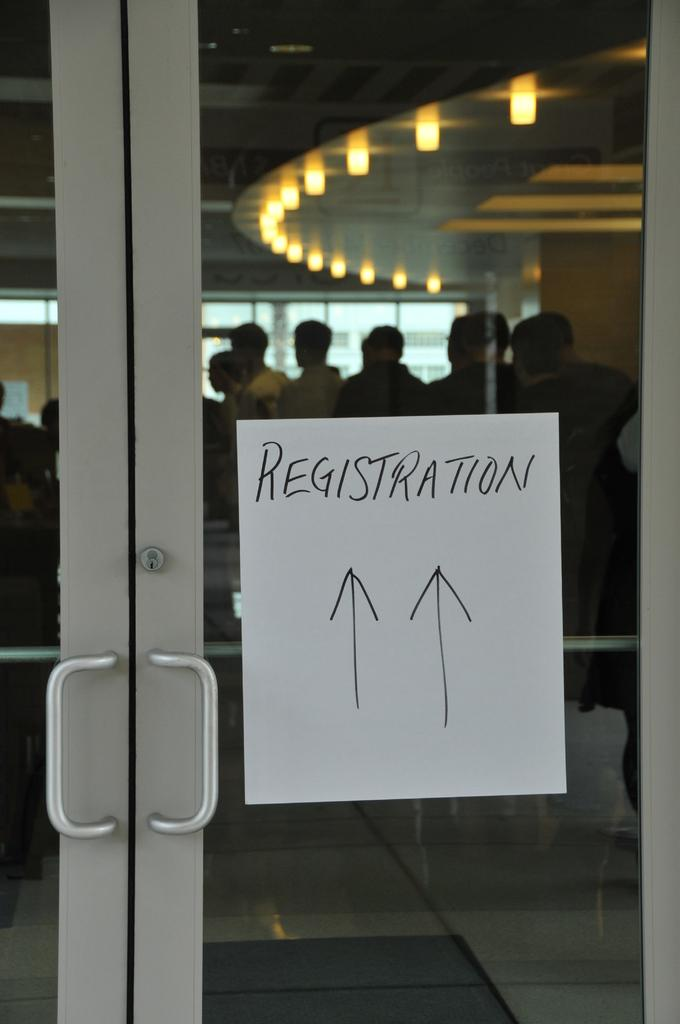What is written on the paper in the image? The facts do not specify the content of the text on the paper. What is the purpose of the arrow marks in the image? The arrow marks are attached to a door, which suggests they might indicate direction or provide instructions. Who are the people inside the door in the image? The facts do not provide information about the people inside the door. What type of lights are attached to the roof in the image? The facts do not specify the type of lights attached to the roof. How does the bubble affect the control of the team in the image? There is no bubble or team present in the image. 